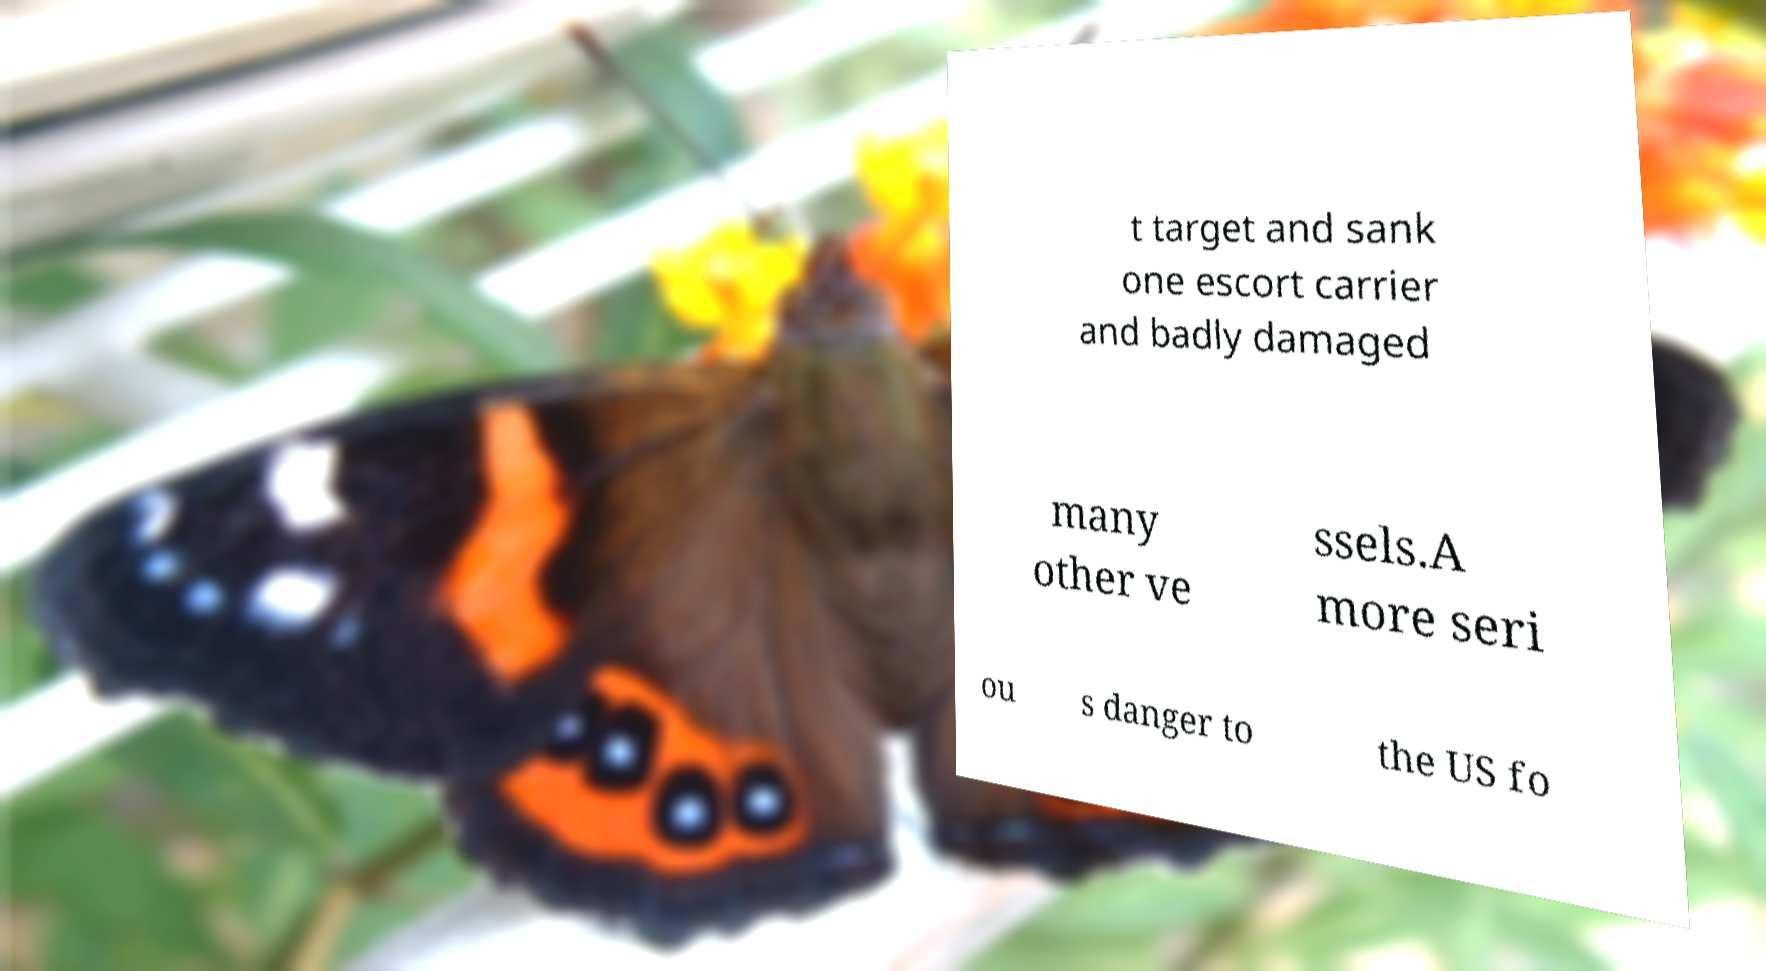I need the written content from this picture converted into text. Can you do that? t target and sank one escort carrier and badly damaged many other ve ssels.A more seri ou s danger to the US fo 